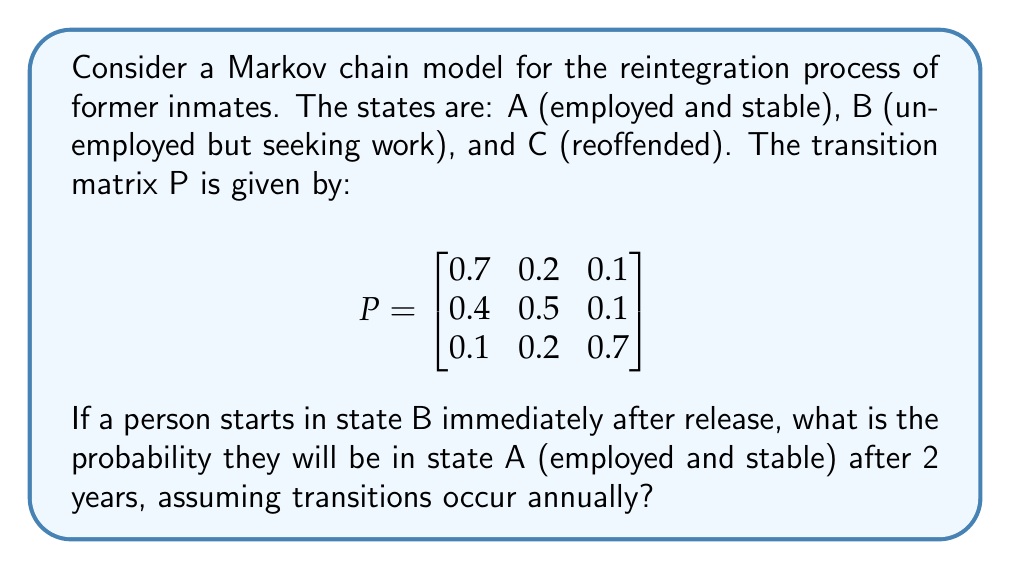Give your solution to this math problem. To solve this problem, we need to use the Chapman-Kolmogorov equations and calculate $P^2$, as we're interested in the state after 2 transitions.

Step 1: Calculate $P^2$
$$P^2 = P \times P = \begin{bmatrix}
0.7 & 0.2 & 0.1 \\
0.4 & 0.5 & 0.1 \\
0.1 & 0.2 & 0.7
\end{bmatrix} \times \begin{bmatrix}
0.7 & 0.2 & 0.1 \\
0.4 & 0.5 & 0.1 \\
0.1 & 0.2 & 0.7
\end{bmatrix}$$

Step 2: Perform matrix multiplication
$$P^2 = \begin{bmatrix}
0.58 & 0.27 & 0.15 \\
0.49 & 0.36 & 0.15 \\
0.22 & 0.29 & 0.49
\end{bmatrix}$$

Step 3: Identify the probability of transitioning from state B to state A after 2 years
The probability we're looking for is the element in the 2nd row (starting state B) and 1st column (ending state A) of $P^2$, which is 0.49.
Answer: 0.49 